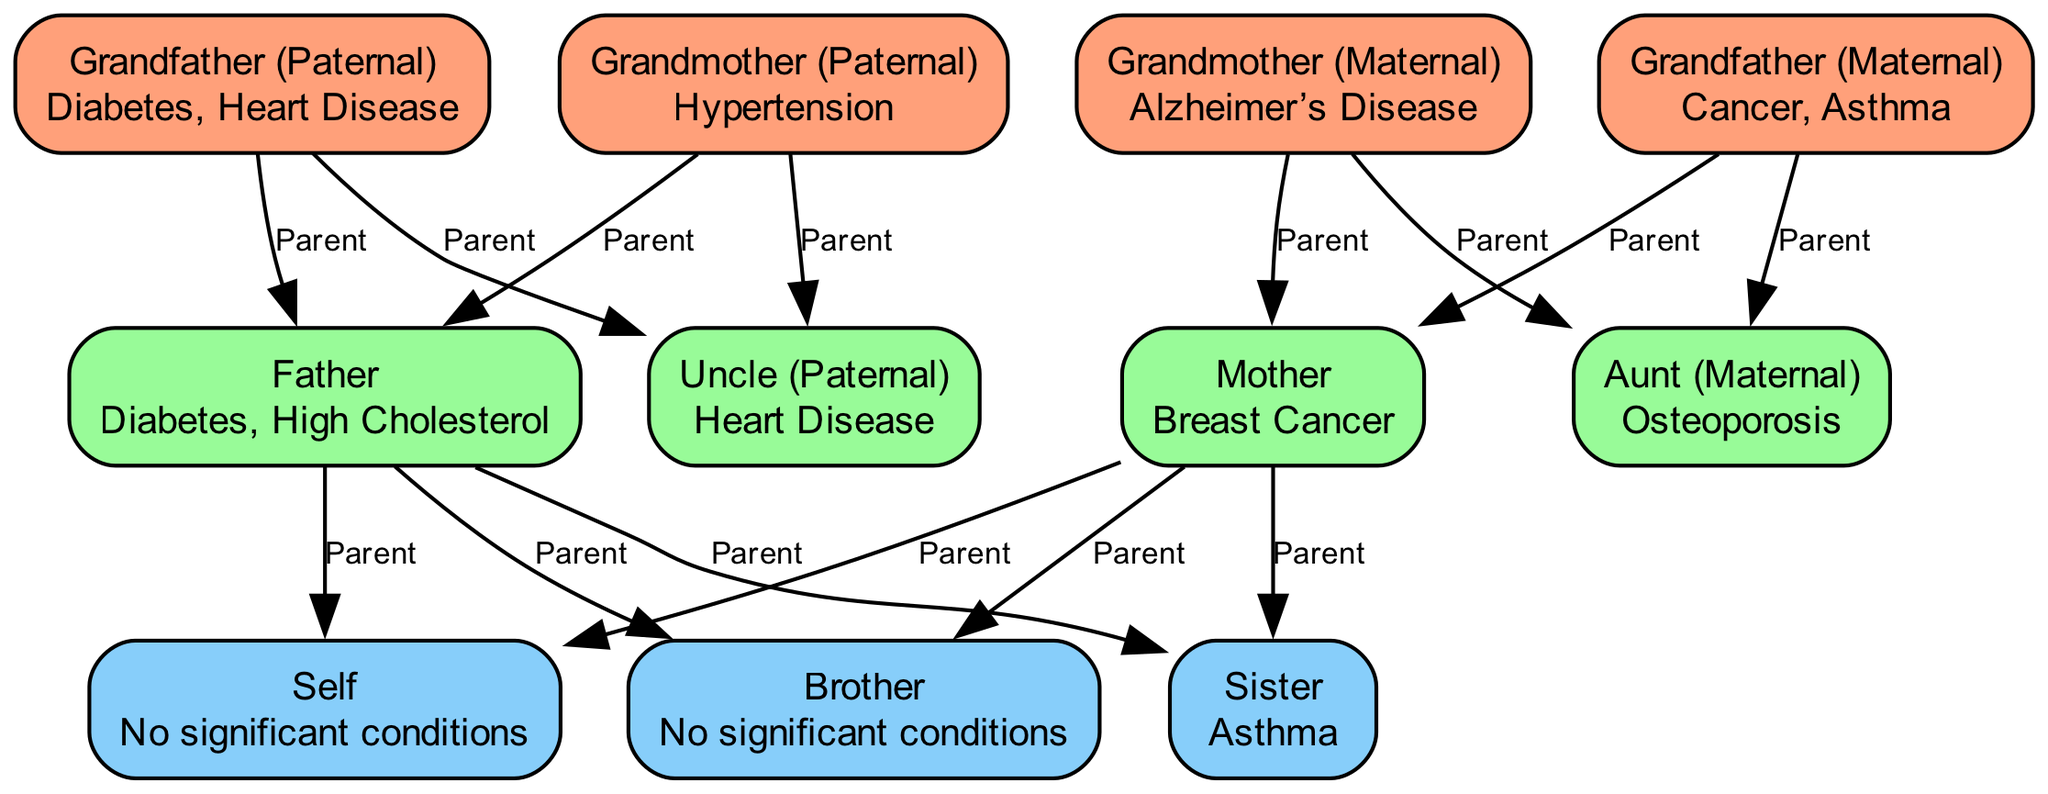What medical condition is listed for the paternal grandmother? The paternal grandmother node displays the label "Grandmother (Paternal)" and the info "Hypertension." Therefore, the medical condition is directly taken from the info section of that node.
Answer: Hypertension How many nodes are in the diagram? The total number of nodes can be counted from the provided data, and there are 11 unique nodes listed under "nodes."
Answer: 11 Who is identified as having asthma? The node labeled "Sister" indicates her info is "Asthma." This identifies the individual from the diagram relative to this condition, which focuses on their personal health issue.
Answer: Sister What relationship links the father to the self? The edge connects the node labeled "Father" to the node labeled "Self," annotated with the relationship "Parent." This clearly identifies the direct parent-child connection as indicated in the diagram.
Answer: Parent Which family member has a history of Alzheimer's Disease? Looking at the node labeled "Grandmother (Maternal)," we see that her info indicates she has "Alzheimer’s Disease." This directly shows which family member is associated with this condition.
Answer: Grandmother (Maternal) How many significant health conditions are reported in total for the parents? The father has "Diabetes" and "High Cholesterol," while the mother has "Breast Cancer." Adding these conditions gives a total of 3 significant health conditions recorded for the parents from the info provided.
Answer: 3 Which uncle has a medical condition, and what is it? The "Uncle (Paternal)" node states the condition "Heart Disease." Thus, this question targets the specific uncle and his health condition as stated in the diagram.
Answer: Heart Disease What is the profession of the self? The node labeled "Self" does not list any significant conditions, but it does not represent a profession. It simply refers to the individual depicted in the chart, making profession irrelevant in this context. It would be more about health history.
Answer: No significant conditions Are there any family members listed with no significant conditions? Both the self and the brother nodes contain the info "No significant conditions." This means that these two family members are highlighted as not having notable health issues in the diagram.
Answer: Self, Brother 